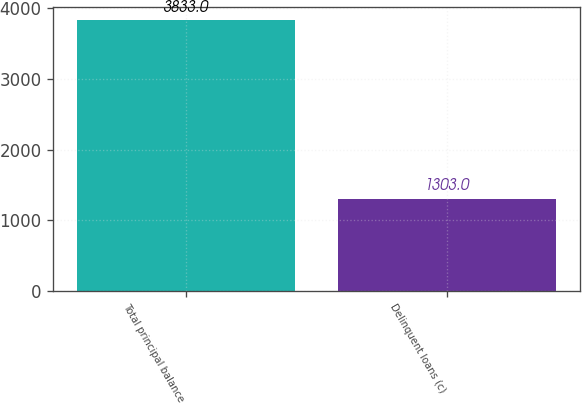Convert chart. <chart><loc_0><loc_0><loc_500><loc_500><bar_chart><fcel>Total principal balance<fcel>Delinquent loans (c)<nl><fcel>3833<fcel>1303<nl></chart> 